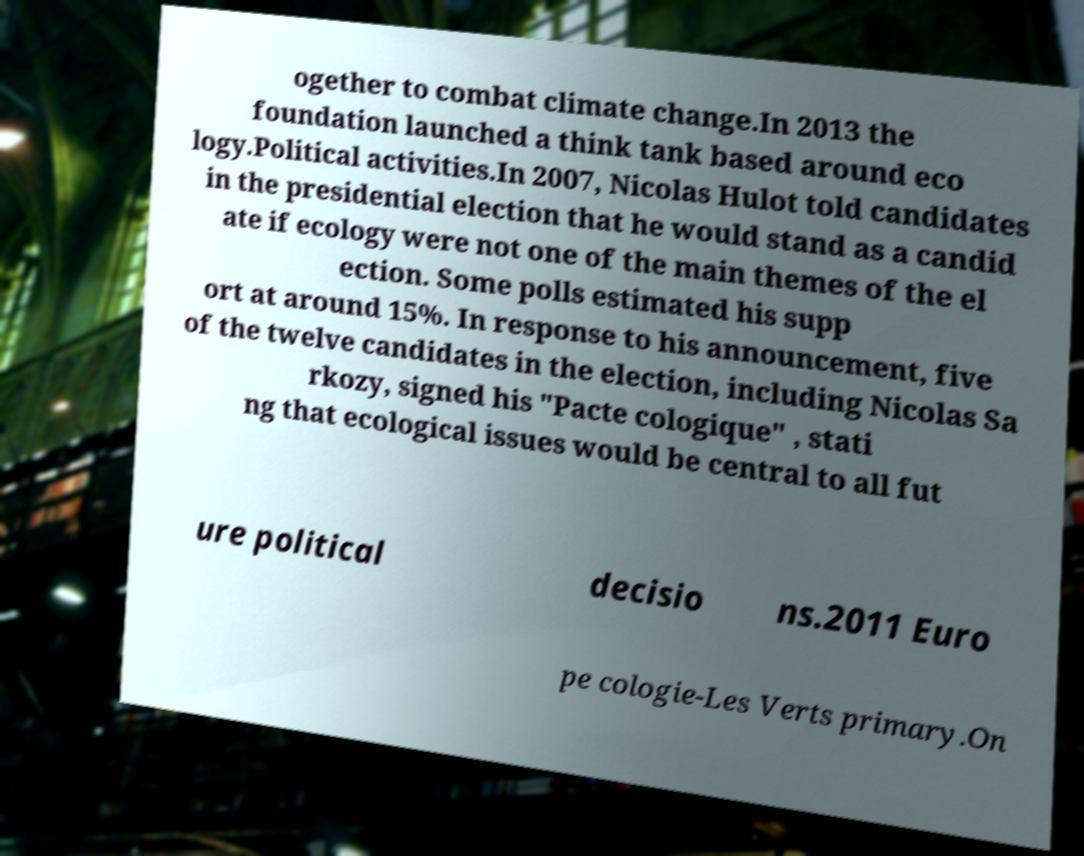I need the written content from this picture converted into text. Can you do that? ogether to combat climate change.In 2013 the foundation launched a think tank based around eco logy.Political activities.In 2007, Nicolas Hulot told candidates in the presidential election that he would stand as a candid ate if ecology were not one of the main themes of the el ection. Some polls estimated his supp ort at around 15%. In response to his announcement, five of the twelve candidates in the election, including Nicolas Sa rkozy, signed his "Pacte cologique" , stati ng that ecological issues would be central to all fut ure political decisio ns.2011 Euro pe cologie-Les Verts primary.On 